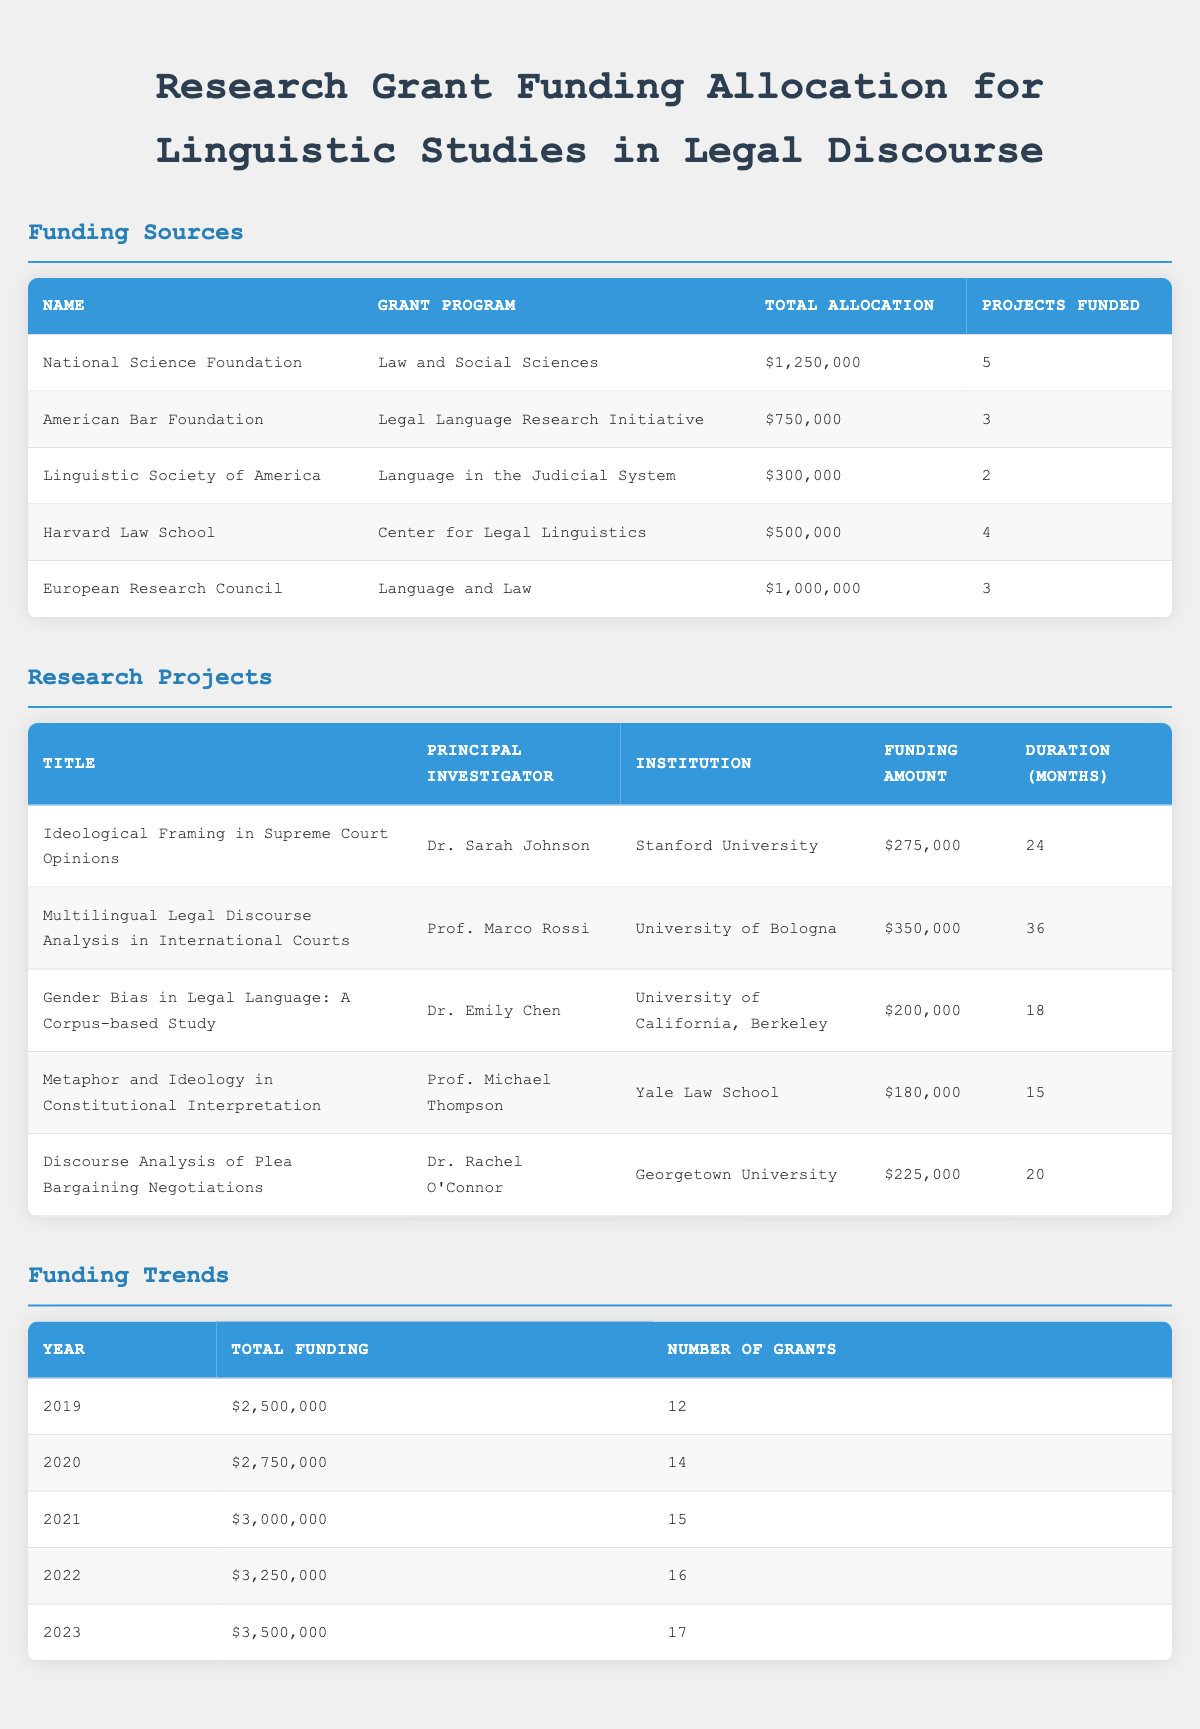What is the total funding allocated by the National Science Foundation? According to the table, the total allocation from the National Science Foundation is explicitly listed as $1,250,000.
Answer: $1,250,000 How many projects were funded by the American Bar Foundation? The table shows that the American Bar Foundation funded a total of 3 projects, as indicated in the "Projects Funded" column.
Answer: 3 What is the average funding amount for projects under the Harvard Law School initiative? The Harvard Law School funded 4 projects, with a total funding amount of $500,000. To find the average, divide the total funding by the number of projects: $500,000 / 4 = $125,000.
Answer: $125,000 Did the Linguistic Society of America fund more or fewer projects than the European Research Council? The table states that the Linguistic Society of America funded 2 projects, while the European Research Council funded 3 projects. Since 2 is fewer than 3, the answer is fewer.
Answer: Fewer What year saw the largest total funding allocation and what was that amount? The funding trends table shows that the year with the largest total funding is 2023, with a total funding amount of $3,500,000.
Answer: 2023, $3,500,000 How much more funding was allocated to the National Science Foundation compared to the Linguistic Society of America? The National Science Foundation's total funding is $1,250,000 and the Linguistic Society of America’s is $300,000. To find the difference: $1,250,000 - $300,000 = $950,000.
Answer: $950,000 Which principal investigator received the least funding for their research project? The research projects table indicates that the principal investigator who received the least funding is Prof. Michael Thompson with $180,000 for the project "Metaphor and Ideology in Constitutional Interpretation."
Answer: Prof. Michael Thompson, $180,000 What is the total number of grants awarded from 2020 to 2022? From the funding trends table, the number of grants awarded in 2020, 2021, and 2022 are 14, 15, and 16 respectively. Adding these gives: 14 + 15 + 16 = 45.
Answer: 45 How does the funding amount for "Discourse Analysis of Plea Bargaining Negotiations" compare to that of "Gender Bias in Legal Language: A Corpus-based Study"? The funding amount for "Discourse Analysis of Plea Bargaining Negotiations" is $225,000, while "Gender Bias in Legal Language: A Corpus-based Study" received $200,000. Comparing these: $225,000 is greater than $200,000.
Answer: Greater 